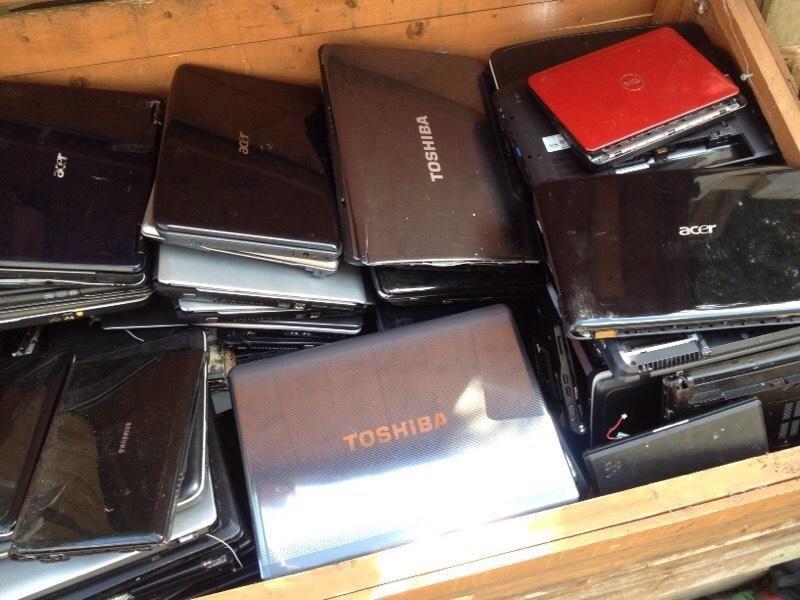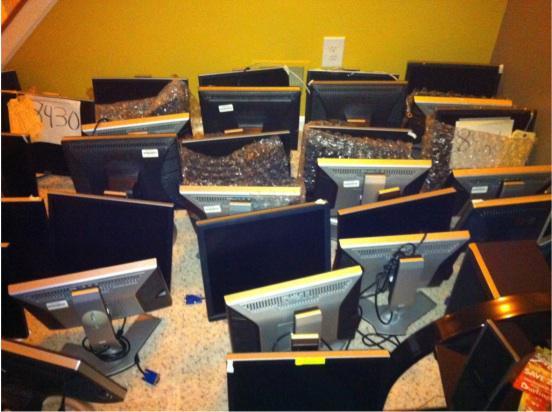The first image is the image on the left, the second image is the image on the right. Considering the images on both sides, is "An image shows one open laptop with at least one hand visible at a side of the image." valid? Answer yes or no. No. The first image is the image on the left, the second image is the image on the right. Considering the images on both sides, is "At least one human hand is near a laptop in the right image." valid? Answer yes or no. No. 